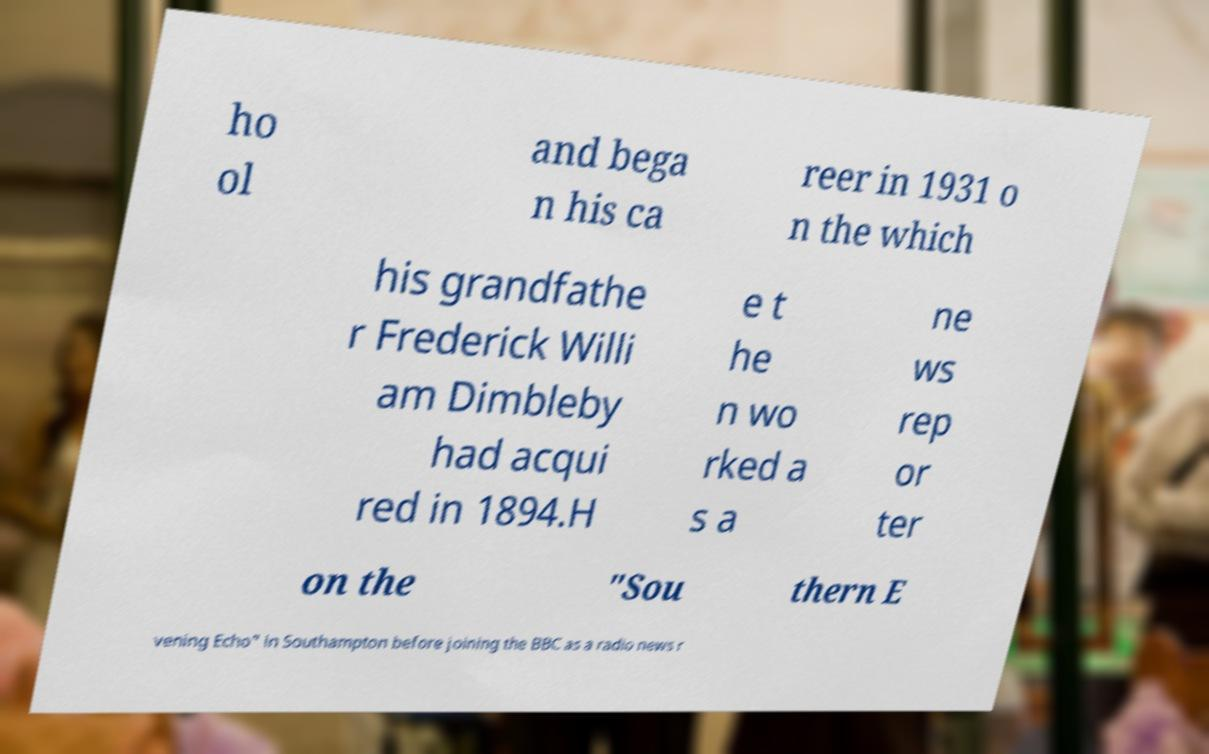Can you read and provide the text displayed in the image?This photo seems to have some interesting text. Can you extract and type it out for me? ho ol and bega n his ca reer in 1931 o n the which his grandfathe r Frederick Willi am Dimbleby had acqui red in 1894.H e t he n wo rked a s a ne ws rep or ter on the "Sou thern E vening Echo" in Southampton before joining the BBC as a radio news r 